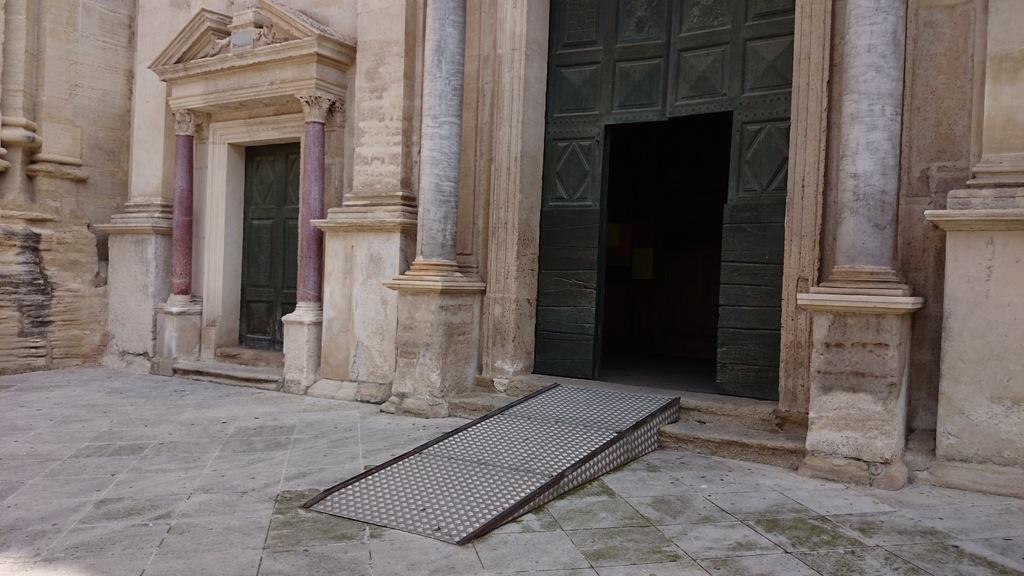What type of structure is visible in the image? There is a building in the image. Can you describe any specific features of the building? There is a green-colored door in the image. What type of pleasure can be seen enjoying the mind in the image? There is no indication of pleasure or a mind in the image; it only features a building with a green-colored door. 